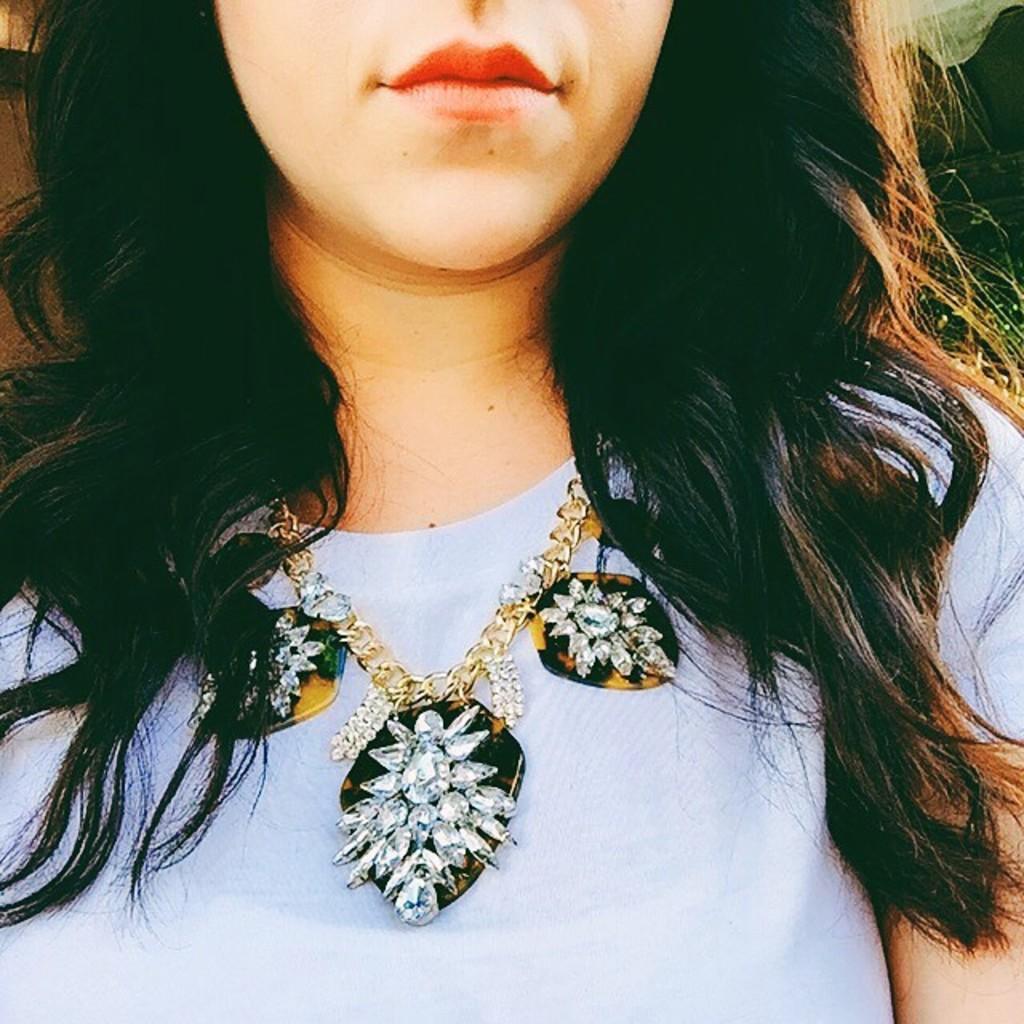Can you describe this image briefly? In this image we can see a woman wearing a necklace. 